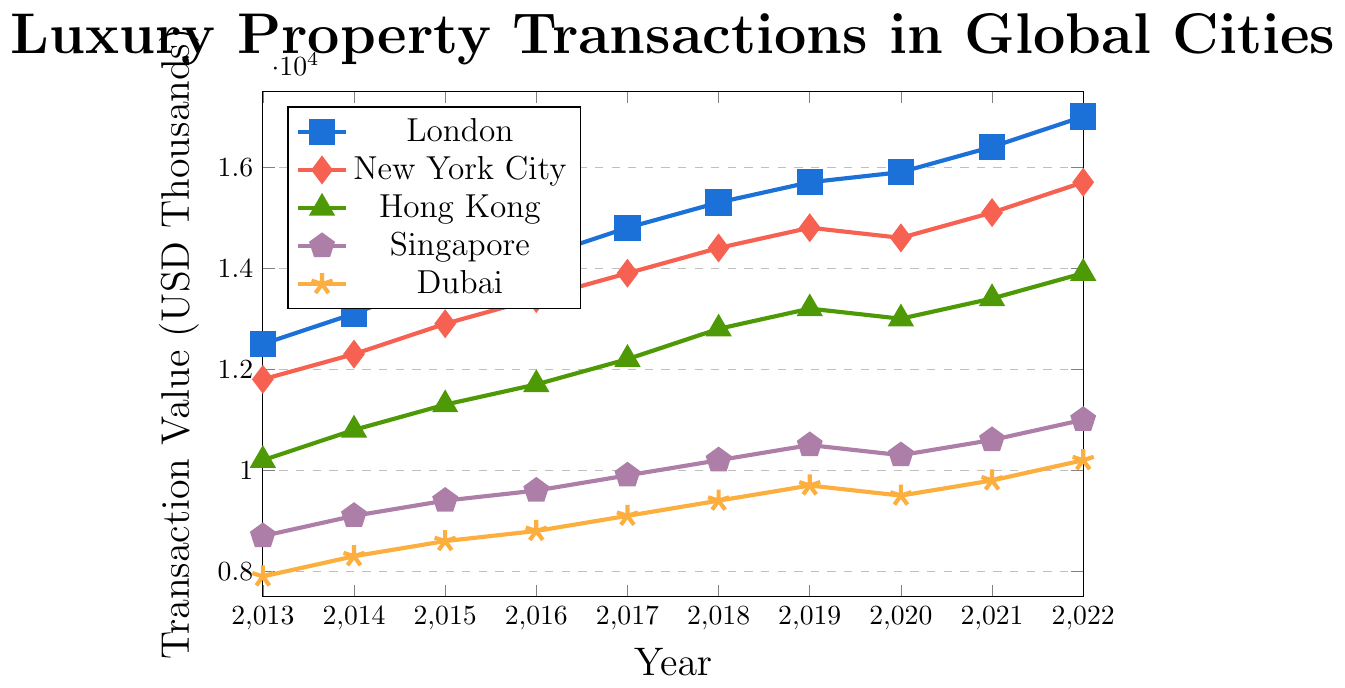Which city's luxury property transactions experienced the highest value in 2022? By examining the end points of each city's trend line for the year 2022, London's trend line is the highest, indicating it has the highest transaction value.
Answer: London How much higher were London's luxury property transactions than New York City's in 2022? Look at the 2022 values for both London (17000) and New York City (15700), then calculate the difference: 17000 - 15700 = 1300.
Answer: 1300 Which city showed the most consistent year-on-year increase in luxury property transactions over the period? By observing the line plots, London's trend line shows a consistent upward trajectory without any declines, indicating a steady and consistent increase year-on-year.
Answer: London How did the value of Hong Kong's luxury property transactions change from 2019 to 2020? By examining Hong Kong's values in 2019 and 2020, you see that it fell from 13200 in 2019 to 13000 in 2020. The change is 13200 - 13000 = 200.
Answer: Decreased by 200 What is the average value of luxury property transactions in Dubai over the observed years? Sum up Dubai's transaction values from 2013 to 2022 (7900 + 8300 + 8600 + 8800 + 9100 + 9400 + 9700 + 9500 + 9800 + 10200) = 92300, then divide by the number of years (10): 92300 / 10 = 9230.
Answer: 9230 In what year did Singapore surpass 10000 in transaction value? By tracing Singapore's line plot, it crosses the 10000 threshold between 2017 and 2018. The value in 2018 is 10200.
Answer: 2018 What was the smallest year-on-year increase in transaction value for New York City? By analyzing the increments between New York City's values, the smallest increase occurred between 2019 and 2020, where the transaction value actually decreased from 14800 to 14600, so the smallest increase is actually a decrease of 200.
Answer: Decrease of 200 Between 2015 and 2020, which city saw the greatest total increase in luxury property transaction values? Calculate the total increase from 2015 to 2020 for each city. London increased by 15900 - 13800 = 2100, New York City by 14600 - 12900 = 1700, Hong Kong by 13000 - 11300 = 1700, Singapore by 10300 - 9400 = 900, Dubai by 9500 - 8600 = 900. Thus, London had the greatest total increase.
Answer: London 